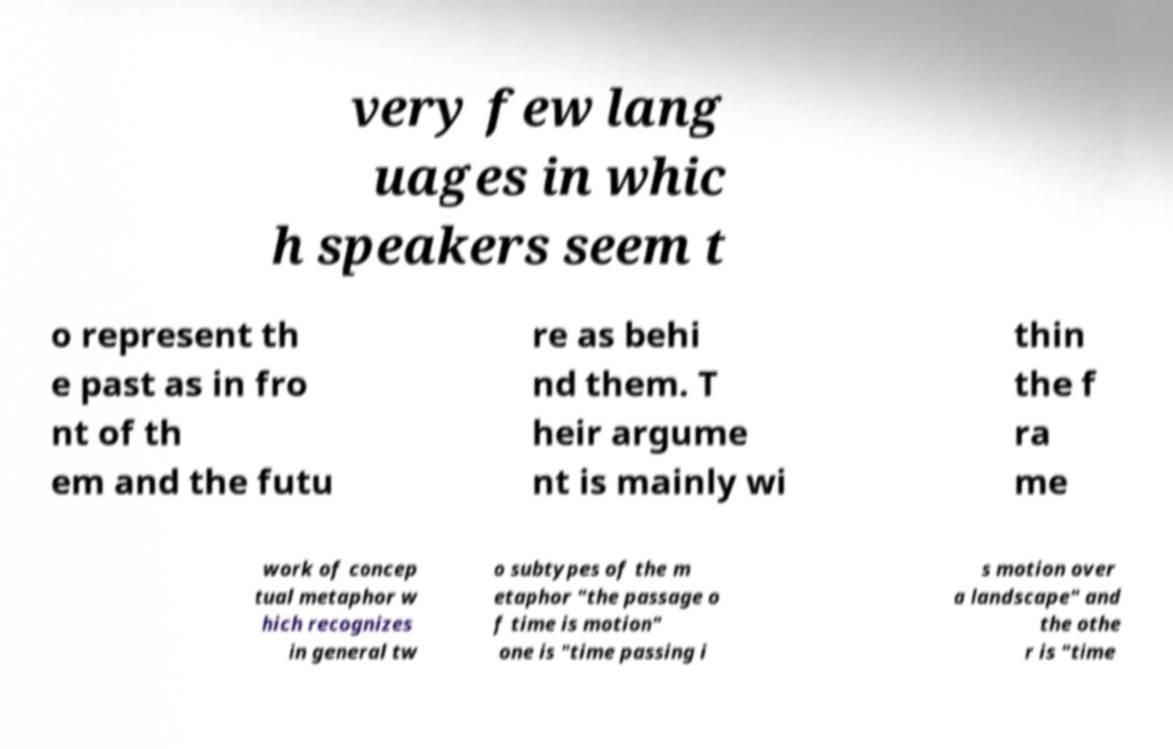Can you accurately transcribe the text from the provided image for me? very few lang uages in whic h speakers seem t o represent th e past as in fro nt of th em and the futu re as behi nd them. T heir argume nt is mainly wi thin the f ra me work of concep tual metaphor w hich recognizes in general tw o subtypes of the m etaphor "the passage o f time is motion" one is "time passing i s motion over a landscape" and the othe r is "time 